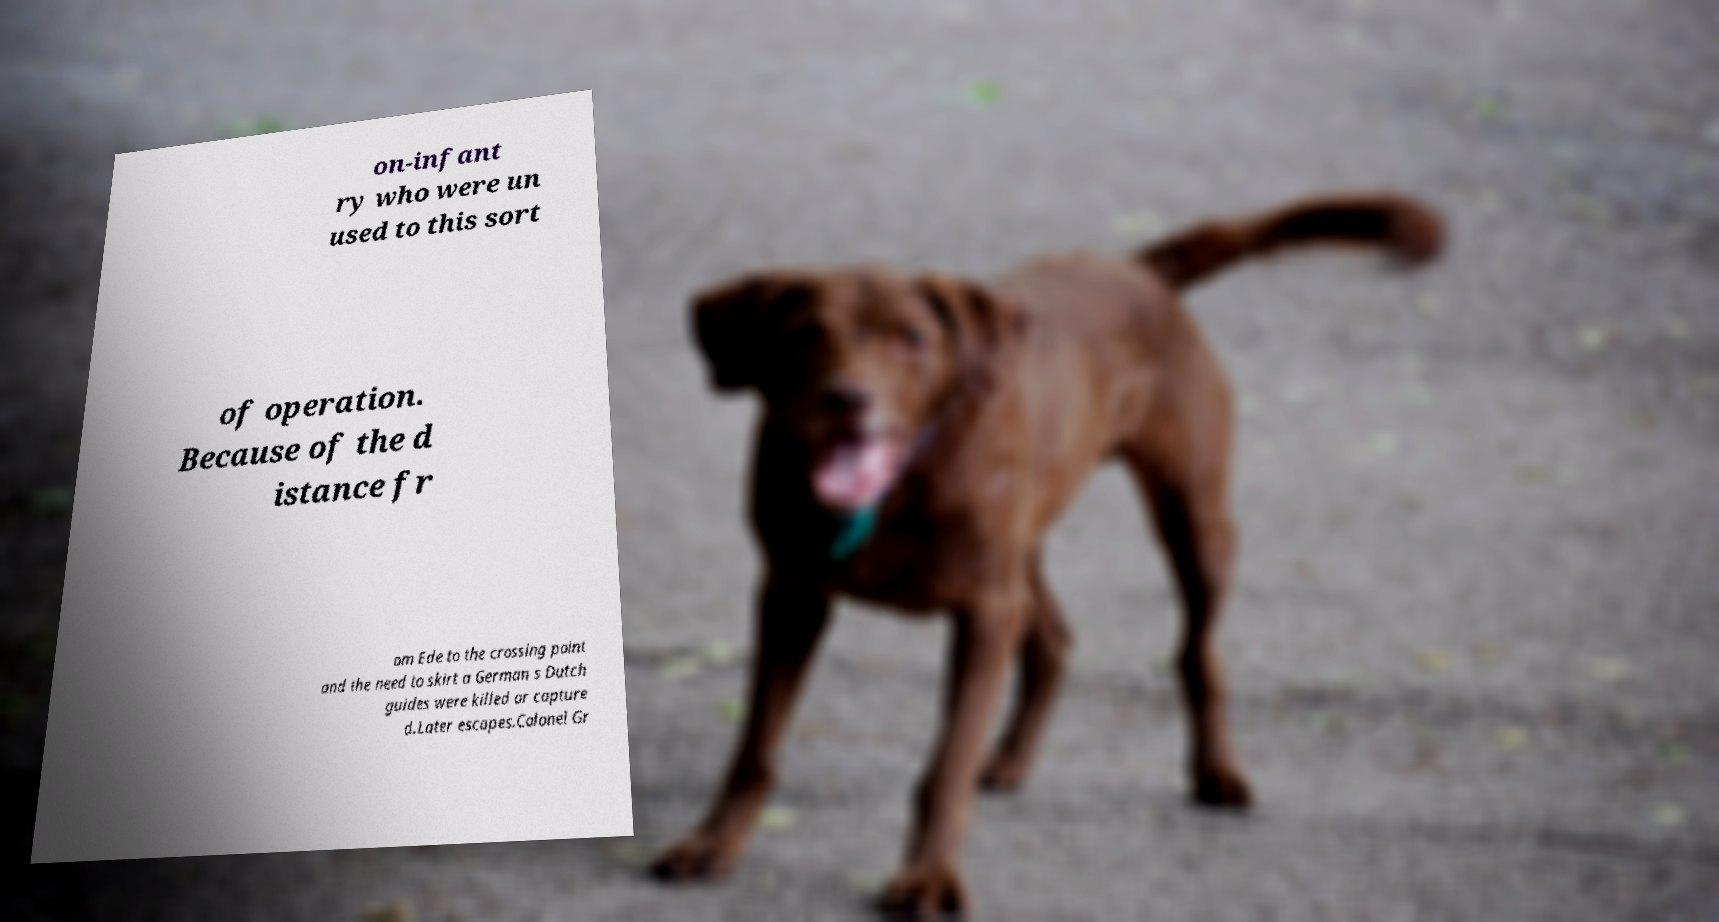Could you extract and type out the text from this image? on-infant ry who were un used to this sort of operation. Because of the d istance fr om Ede to the crossing point and the need to skirt a German s Dutch guides were killed or capture d.Later escapes.Colonel Gr 